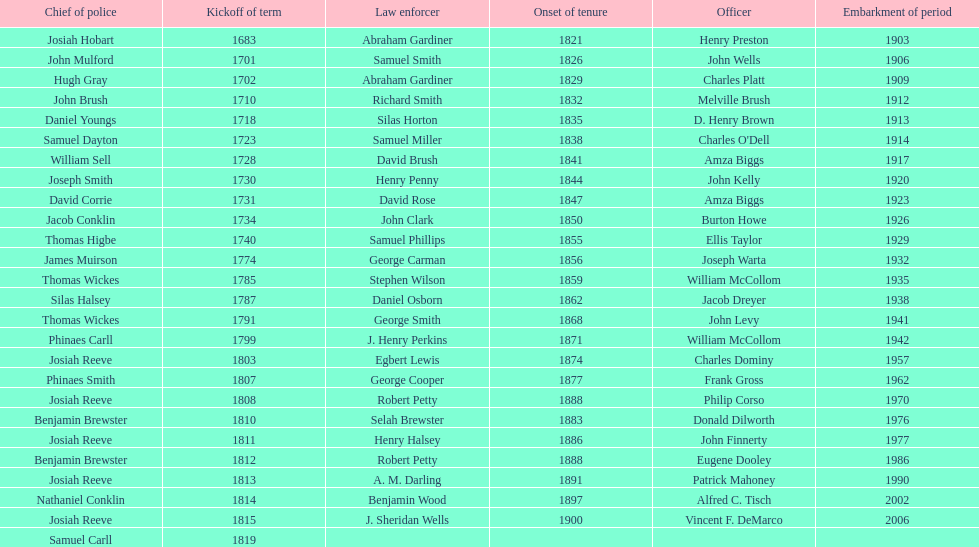Who was the sheriff in suffolk county before amza biggs first term there as sheriff? Charles O'Dell. 